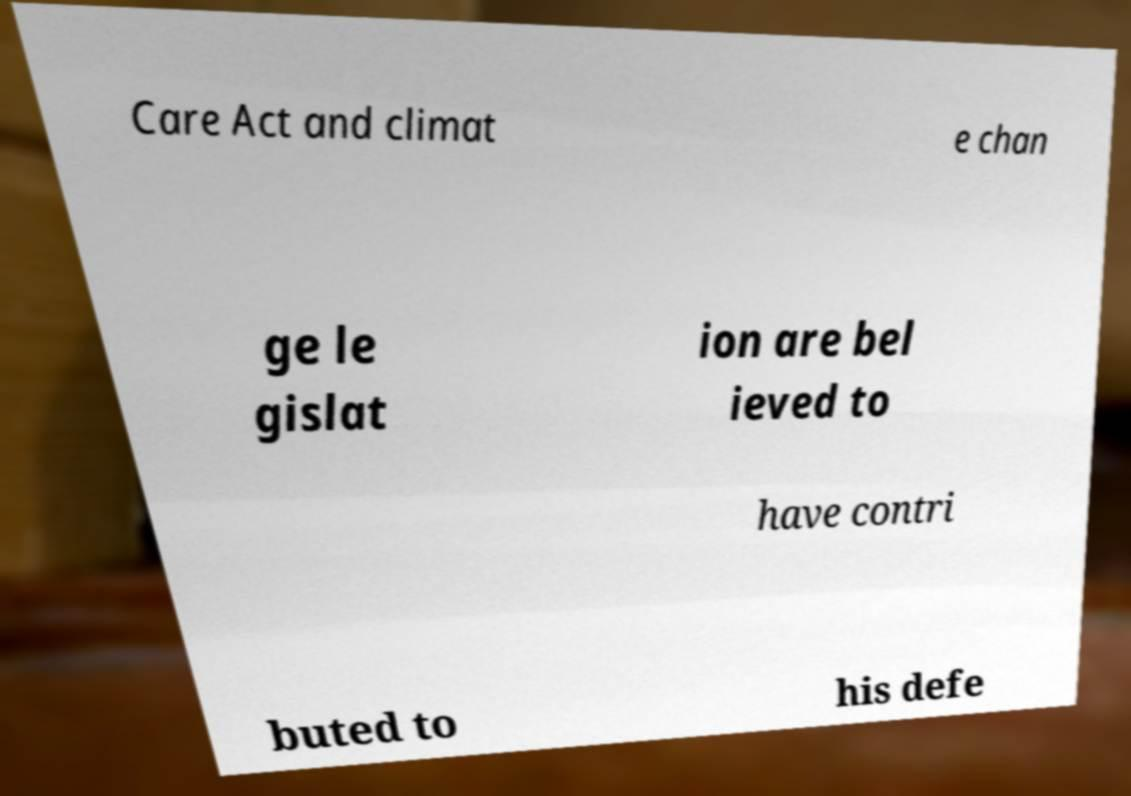What messages or text are displayed in this image? I need them in a readable, typed format. Care Act and climat e chan ge le gislat ion are bel ieved to have contri buted to his defe 